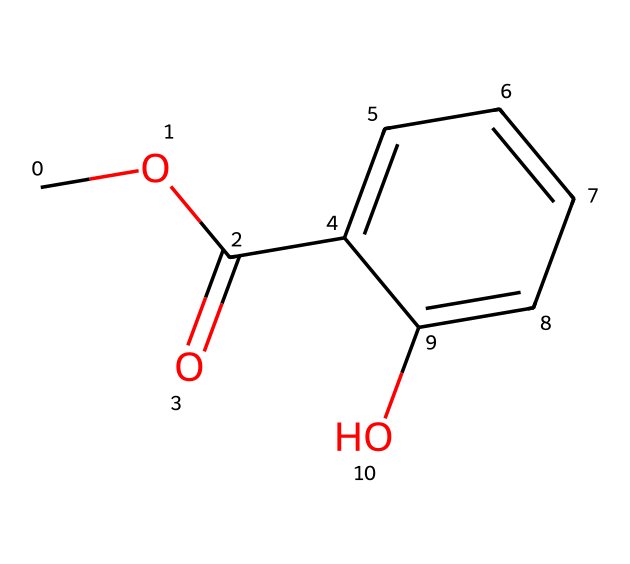What is the molecular formula of methyl salicylate? To determine the molecular formula, count the numbers of each type of atom present in the structure. The SMILES indicates 9 carbons (C), 10 hydrogens (H), 4 oxygens (O). Therefore, the molecular formula is C9H10O4.
Answer: C9H10O4 How many rings are present in the structure of methyl salicylate? Analyzing the structure shows a six-membered aromatic ring and no additional rings, so there is only one ring.
Answer: 1 What functional groups are present in methyl salicylate? The structure includes an ester group (indicated by the -COO- part) and a hydroxyl group (-OH), classifying it as both an ester and a phenol.
Answer: ester and phenol How many oxygen atoms are present in methyl salicylate? The SMILES shows two separate occurrences of the O atom, where one is part of the ester linkage and another one is part of the hydroxyl group. Thus, there are a total of 4 oxygen atoms in the structure.
Answer: 4 Is methyl salicylate a polar or nonpolar compound? The presence of the hydroxyl group contributes to polarity, as well as the ester group. However, the overall structure of methyl salicylate indicates it is polar due to these functional groups.
Answer: polar What is the primary use of methyl salicylate based on its properties? Given that methyl salicylate is known for its analgesic and anti-inflammatory properties, it's primarily used in muscle rubs and pain relief creams.
Answer: muscle rubs and pain relief creams 